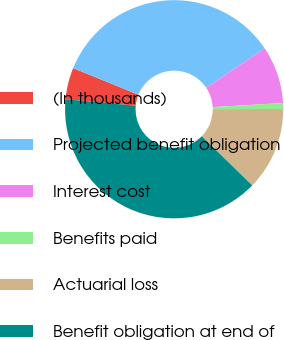Convert chart to OTSL. <chart><loc_0><loc_0><loc_500><loc_500><pie_chart><fcel>(In thousands)<fcel>Projected benefit obligation<fcel>Interest cost<fcel>Benefits paid<fcel>Actuarial loss<fcel>Benefit obligation at end of<nl><fcel>4.69%<fcel>34.41%<fcel>8.52%<fcel>0.86%<fcel>12.35%<fcel>39.16%<nl></chart> 